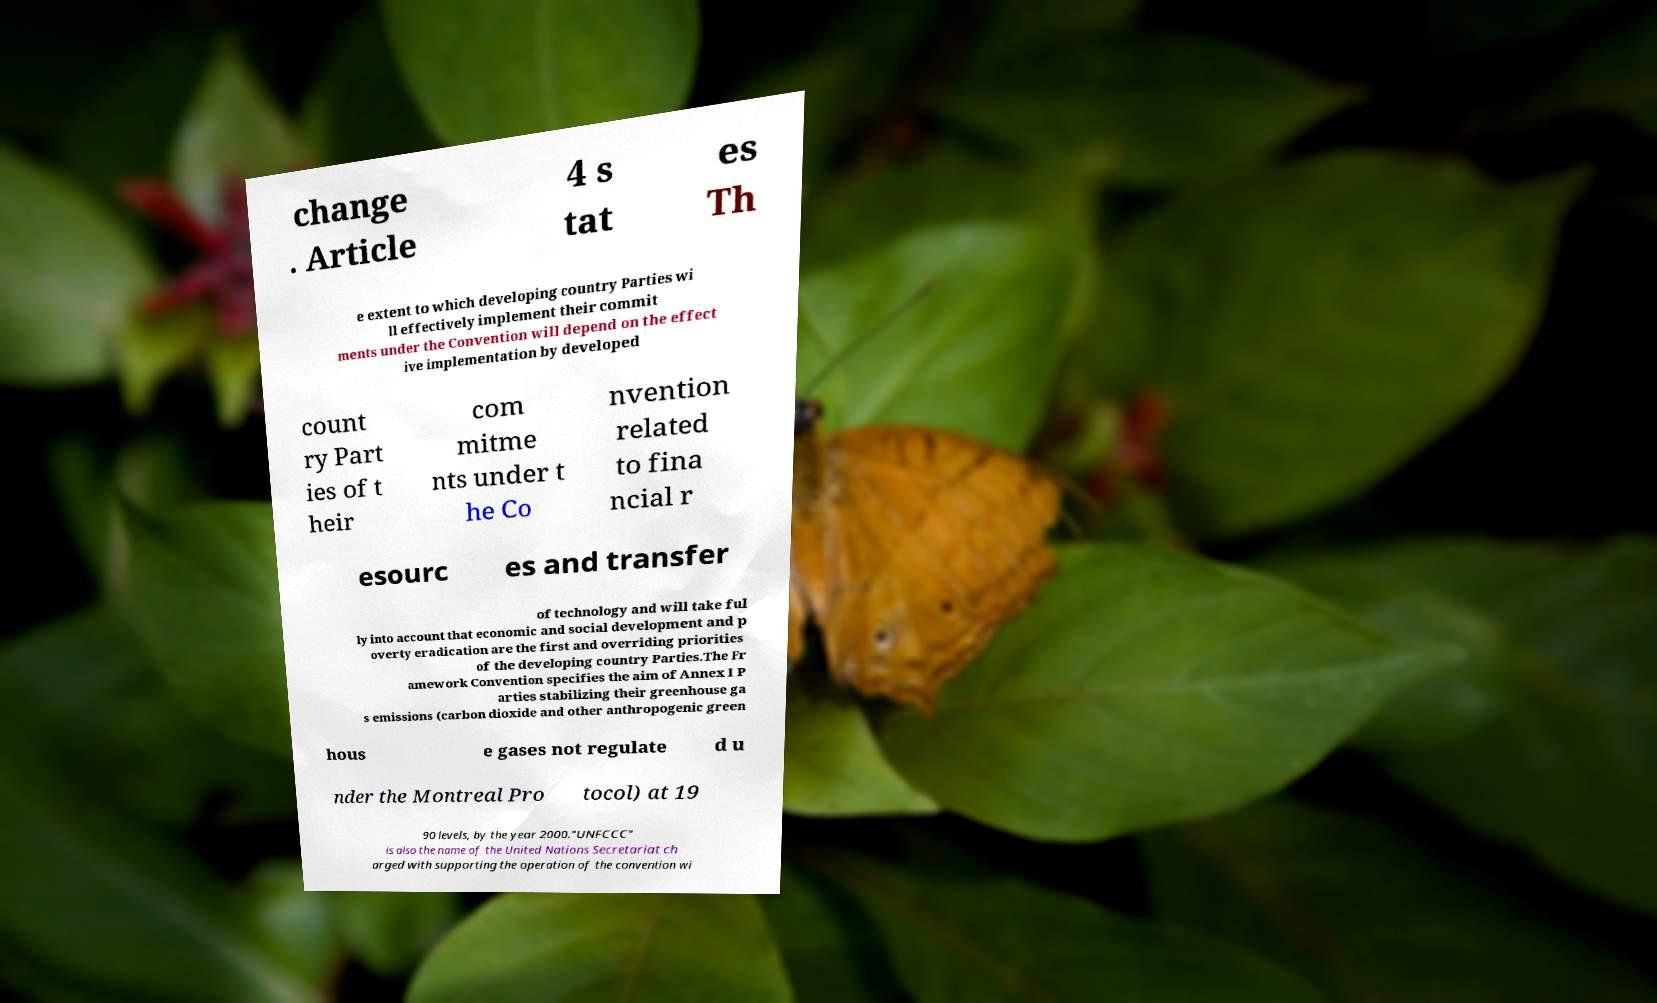I need the written content from this picture converted into text. Can you do that? change . Article 4 s tat es Th e extent to which developing country Parties wi ll effectively implement their commit ments under the Convention will depend on the effect ive implementation by developed count ry Part ies of t heir com mitme nts under t he Co nvention related to fina ncial r esourc es and transfer of technology and will take ful ly into account that economic and social development and p overty eradication are the first and overriding priorities of the developing country Parties.The Fr amework Convention specifies the aim of Annex I P arties stabilizing their greenhouse ga s emissions (carbon dioxide and other anthropogenic green hous e gases not regulate d u nder the Montreal Pro tocol) at 19 90 levels, by the year 2000."UNFCCC" is also the name of the United Nations Secretariat ch arged with supporting the operation of the convention wi 